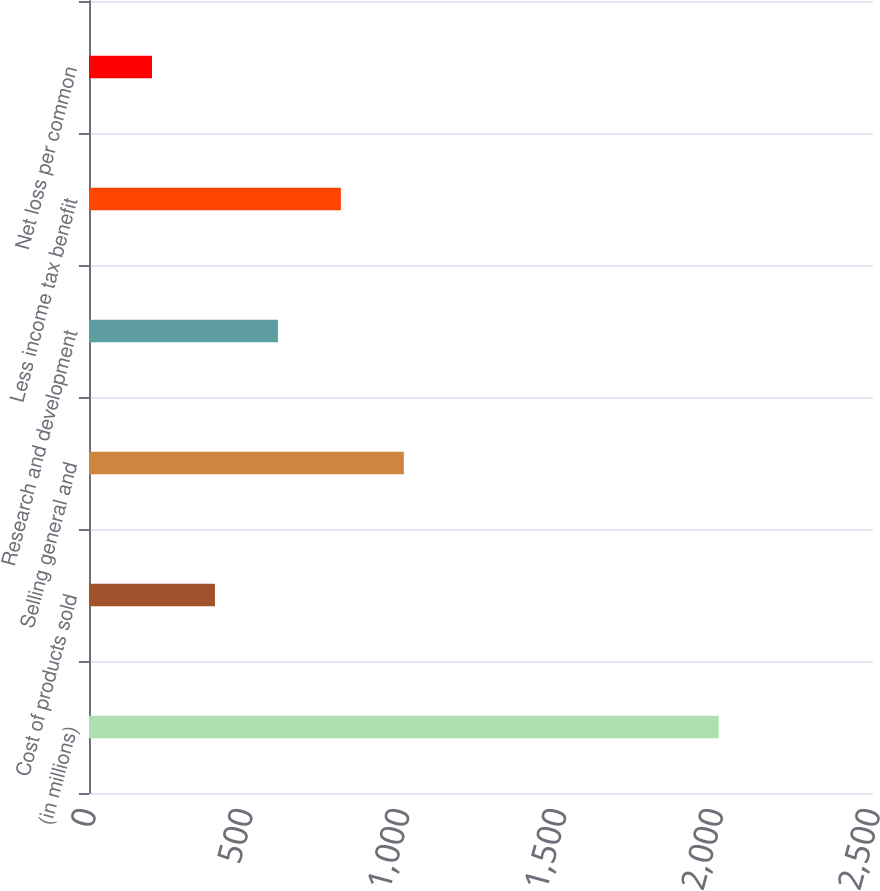Convert chart. <chart><loc_0><loc_0><loc_500><loc_500><bar_chart><fcel>(in millions)<fcel>Cost of products sold<fcel>Selling general and<fcel>Research and development<fcel>Less income tax benefit<fcel>Net loss per common<nl><fcel>2008<fcel>401.64<fcel>1004.01<fcel>602.43<fcel>803.22<fcel>200.85<nl></chart> 